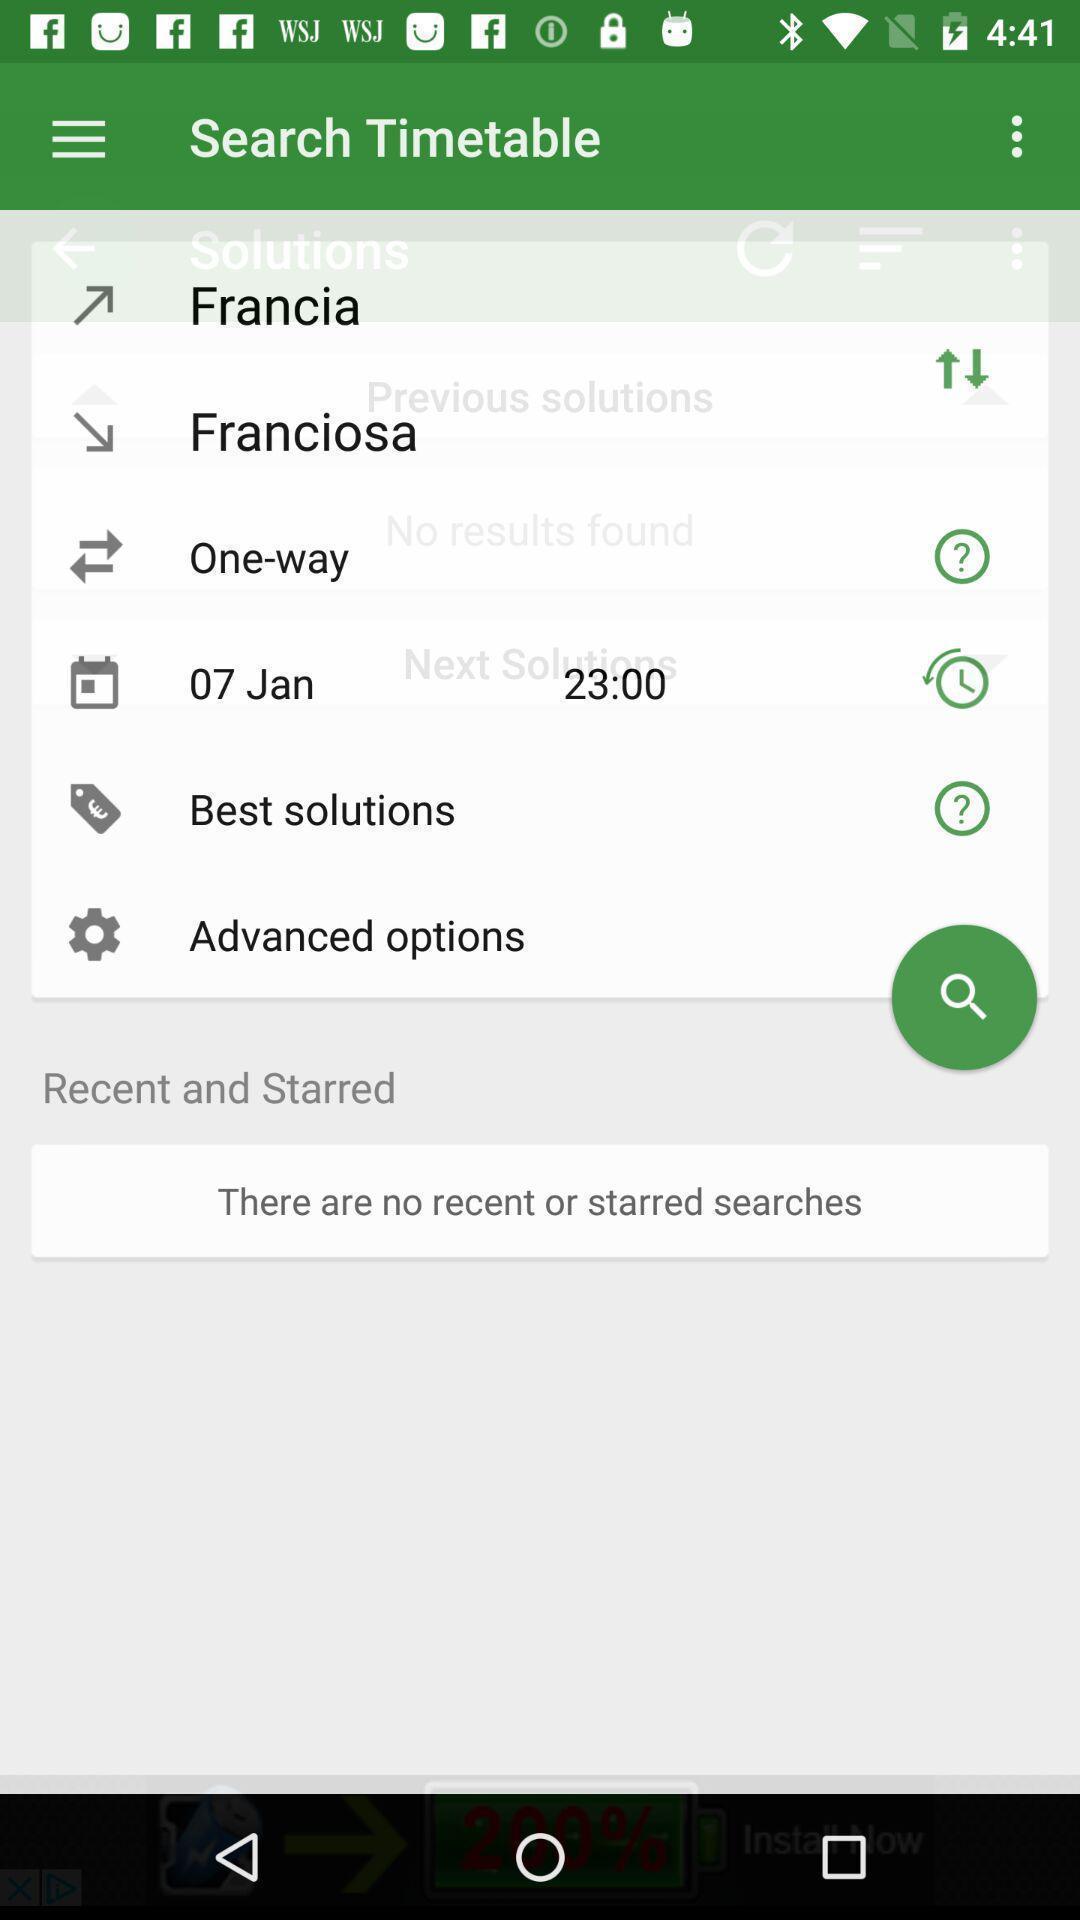Summarize the main components in this picture. Screen display search bar to find train time tables. 